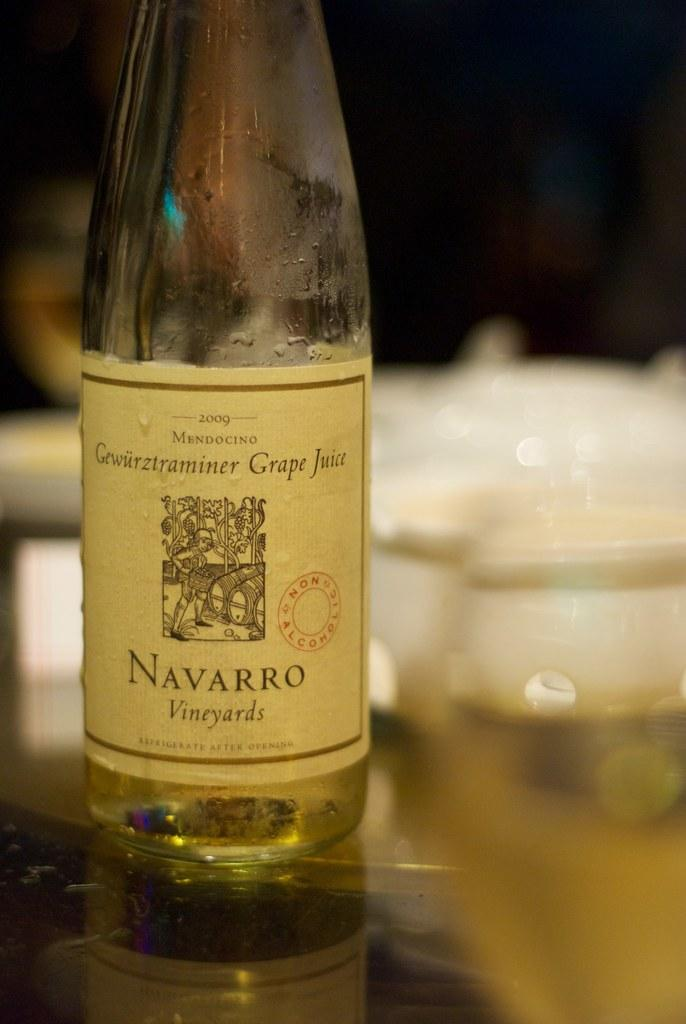Provide a one-sentence caption for the provided image. A bottle of wine on a table that is from Navarro Vineyards. 